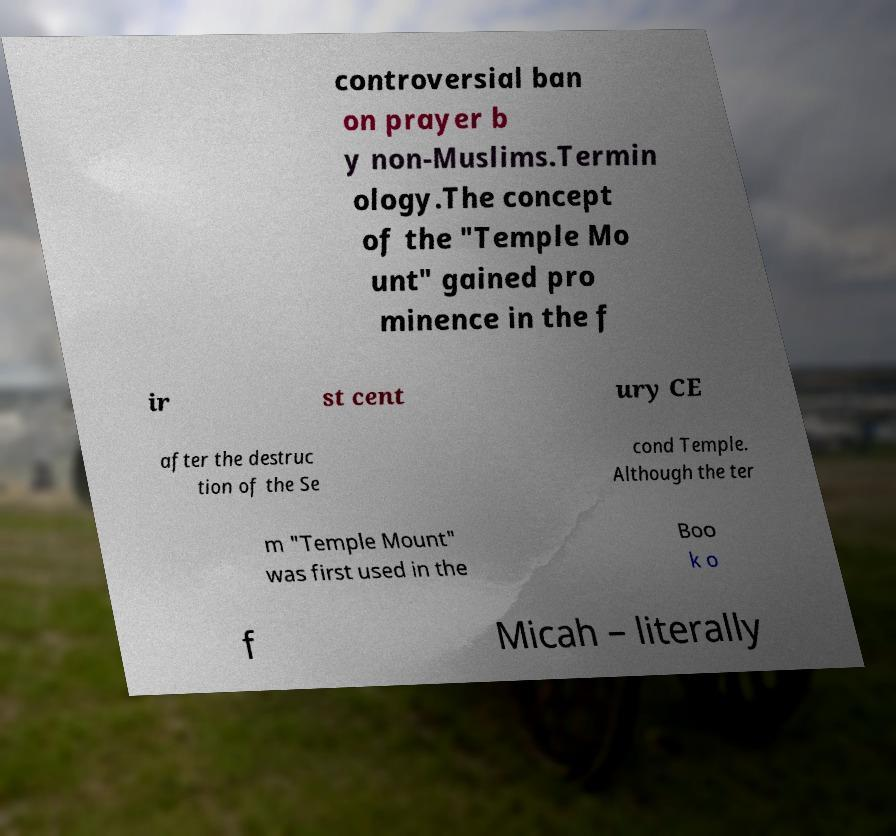Could you assist in decoding the text presented in this image and type it out clearly? controversial ban on prayer b y non-Muslims.Termin ology.The concept of the "Temple Mo unt" gained pro minence in the f ir st cent ury CE after the destruc tion of the Se cond Temple. Although the ter m "Temple Mount" was first used in the Boo k o f Micah – literally 